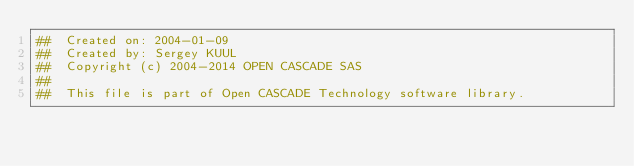Convert code to text. <code><loc_0><loc_0><loc_500><loc_500><_Nim_>##  Created on: 2004-01-09
##  Created by: Sergey KUUL
##  Copyright (c) 2004-2014 OPEN CASCADE SAS
##
##  This file is part of Open CASCADE Technology software library.</code> 